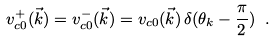<formula> <loc_0><loc_0><loc_500><loc_500>v _ { c 0 } ^ { + } ( \vec { k } ) = v _ { c 0 } ^ { - } ( \vec { k } ) = v _ { c 0 } ( \vec { k } ) \, \delta ( \theta _ { k } - \frac { \pi } { 2 } ) \ .</formula> 